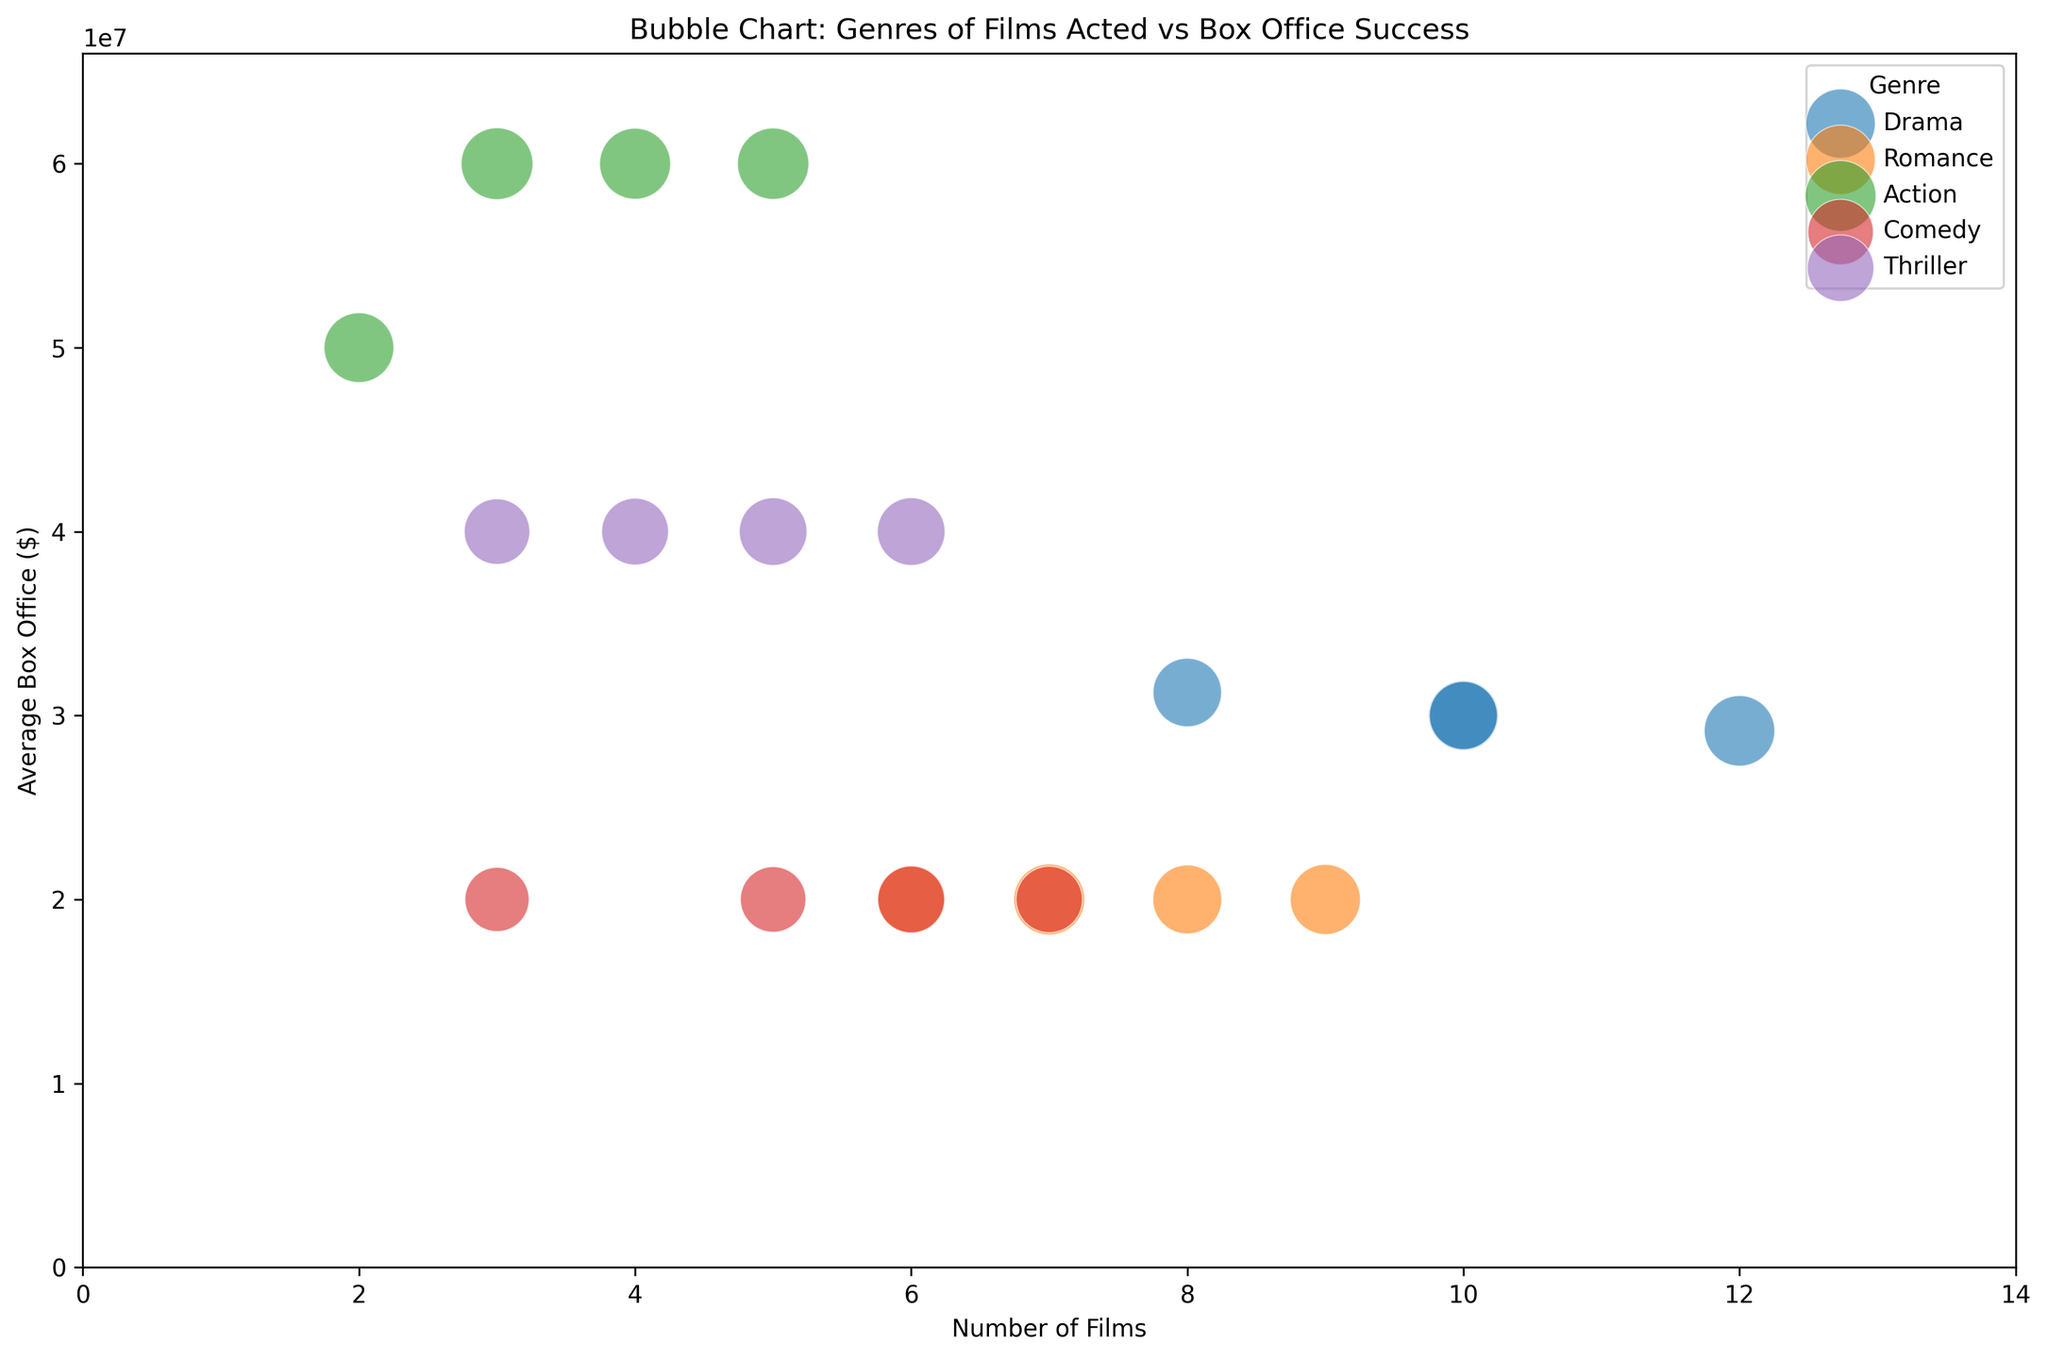What's the average box office success for Drama films across all actresses? First, we identify the average box office values for Drama films for each actress: Actress A - 30M, Actress B - 31.25M, Actress C - 29.17M, Actress D - 30M. We then calculate the average: (30M + 31.25M + 29.17M + 30M) / 4 = 30.105M.
Answer: 30.105M Which genre has the largest bubble size in the plot? We identify the bubbles representing different genres and compare their sizes (Fame_Index). The largest bubble size is for the Action genre, which corresponds to the highest Fame_Index values of 90 for Actress A.
Answer: Action How does the average box office for Thriller films for Actress A compare to Actress C? For Thriller films, the average box office for Actress A is 40M, and for Actress C, it is also 40M. Therefore, they are equal.
Answer: Equal Which actress has the highest average box office for Action films? From the plot, we observe the average box office values for Action films: Actress A - 60M, Actress B - 50M, Actress C - 60M, and Actress D - 60M. All the actresses tied have the highest value.
Answer: Tied (Actress A, Actress C, Actress D) What is the combined number of films in the Romance genre for Actress B and Actress D? From the data, Actress B has 7 Romance films and Actress D has 9 Romance films. Adding them together gives 7 + 9 = 16.
Answer: 16 